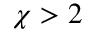<formula> <loc_0><loc_0><loc_500><loc_500>\chi > 2</formula> 